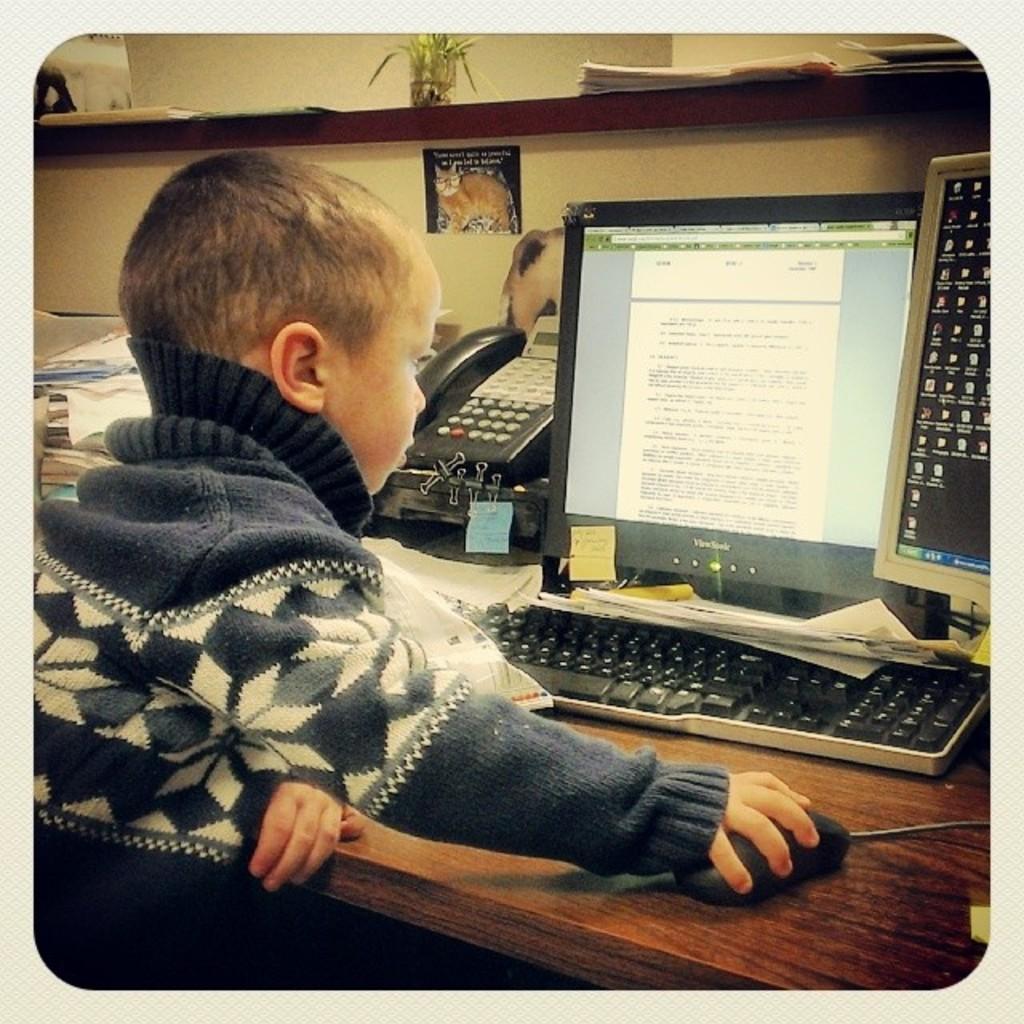How would you summarize this image in a sentence or two? In the picture I can see a boy is operating a computer mouse with the hand. I can also see monitors, a telephone, a keyboard and some other objects on a wooden table. In the background I can see a wall and some objects on a shelf. 